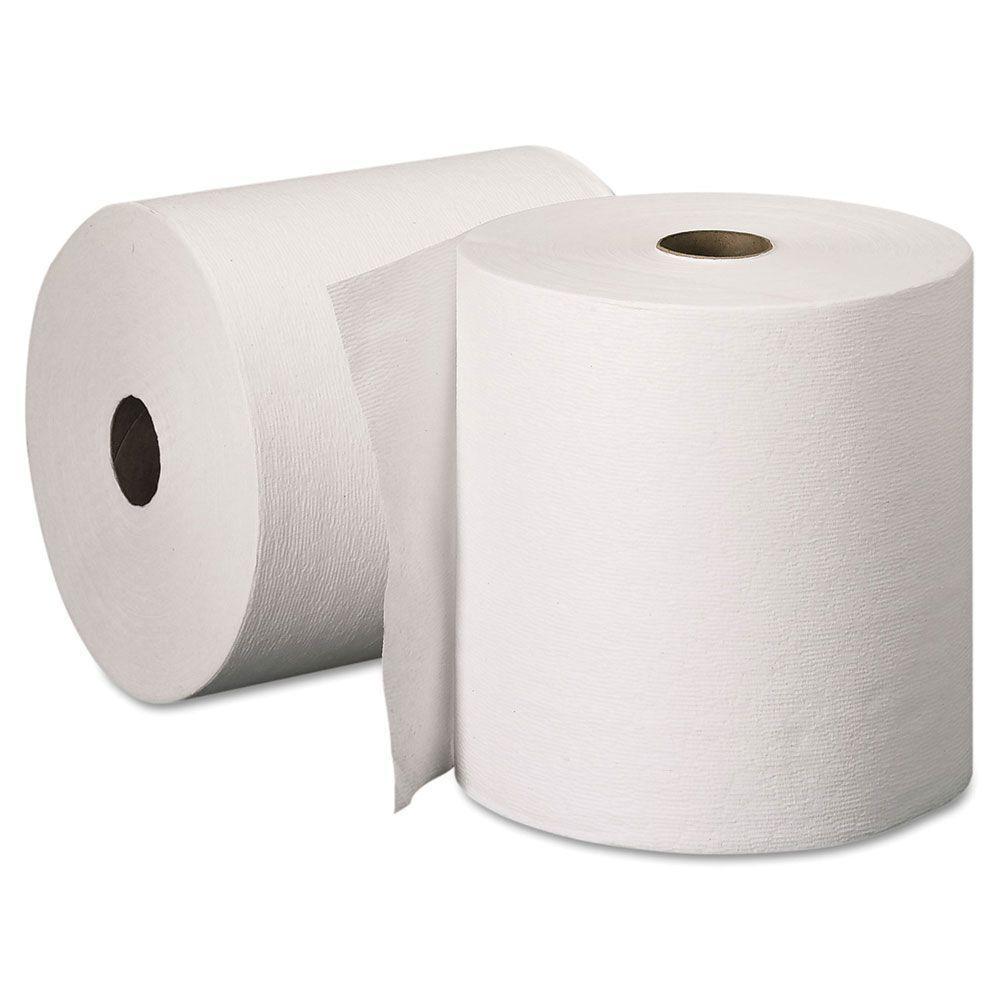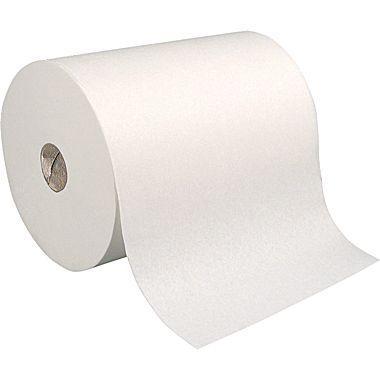The first image is the image on the left, the second image is the image on the right. Given the left and right images, does the statement "An image features one upright towel row the color of brown kraft paper." hold true? Answer yes or no. No. The first image is the image on the left, the second image is the image on the right. For the images shown, is this caption "The roll of paper in one of the image is brown." true? Answer yes or no. No. 